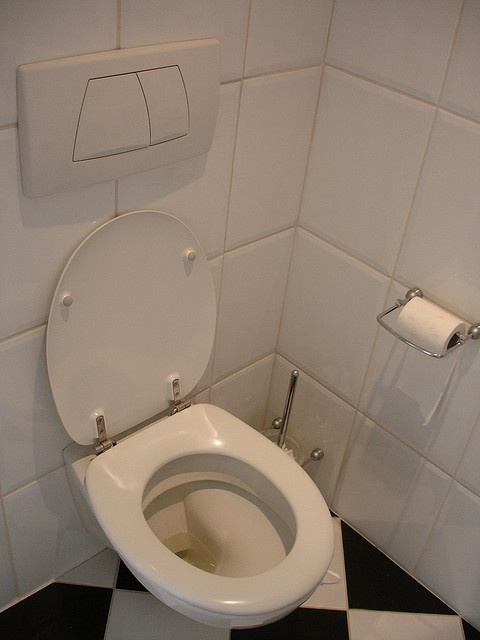Describe the objects in this image and their specific colors. I can see a toilet in gray and tan tones in this image. 